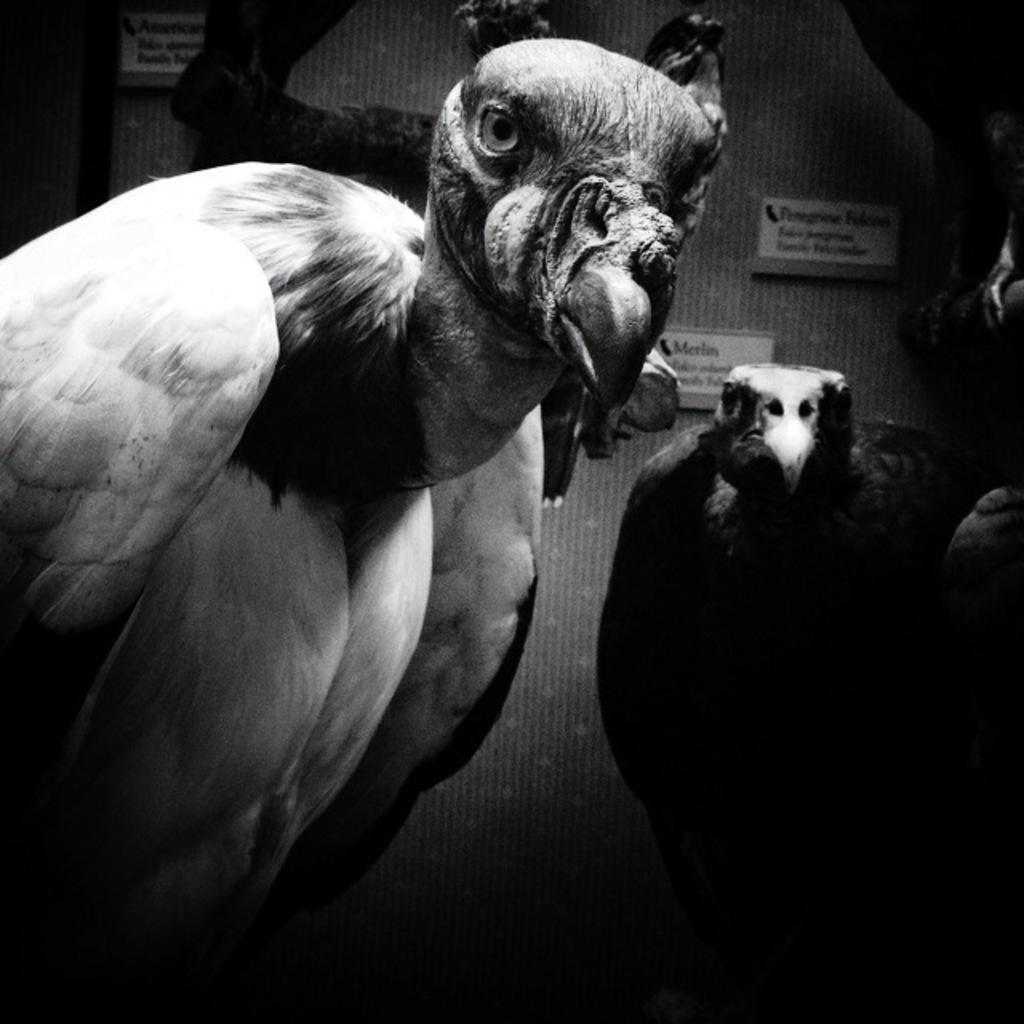What is the color scheme of the image? The image is black and white. What animals can be seen in the picture? There are two eagles in the picture. What is present in the background of the image? There are posters attached to the wall in the background. What type of pleasure can be seen being enjoyed by the eagles in the image? There is no indication of pleasure or any activity being enjoyed by the eagles in the image. Is there any evidence of a crime being committed in the image? There is no indication of a crime or any criminal activity in the image. 